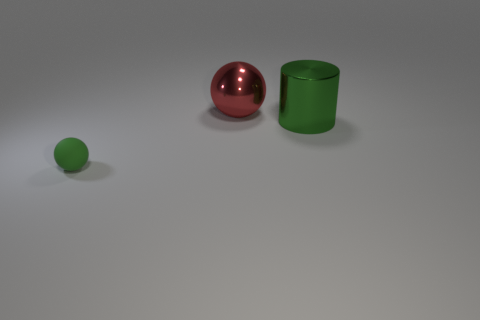Add 2 cylinders. How many objects exist? 5 Subtract all green balls. How many balls are left? 1 Subtract all balls. How many objects are left? 1 Add 1 small rubber balls. How many small rubber balls are left? 2 Add 1 matte objects. How many matte objects exist? 2 Subtract 0 blue cylinders. How many objects are left? 3 Subtract 1 cylinders. How many cylinders are left? 0 Subtract all cyan balls. Subtract all gray blocks. How many balls are left? 2 Subtract all large green cylinders. Subtract all cylinders. How many objects are left? 1 